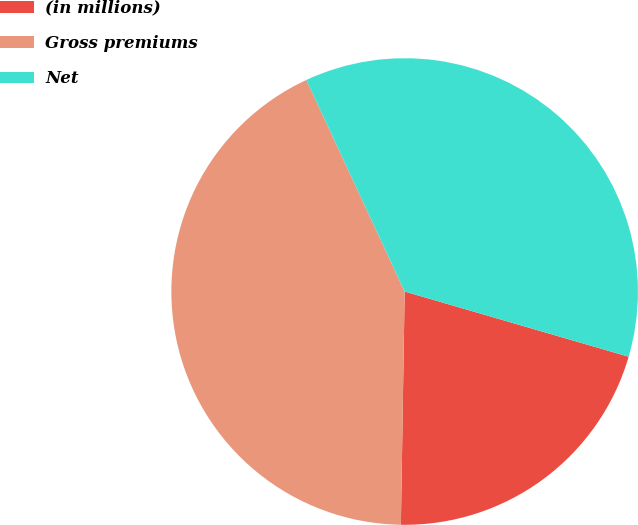Convert chart to OTSL. <chart><loc_0><loc_0><loc_500><loc_500><pie_chart><fcel>(in millions)<fcel>Gross premiums<fcel>Net<nl><fcel>20.75%<fcel>42.82%<fcel>36.43%<nl></chart> 